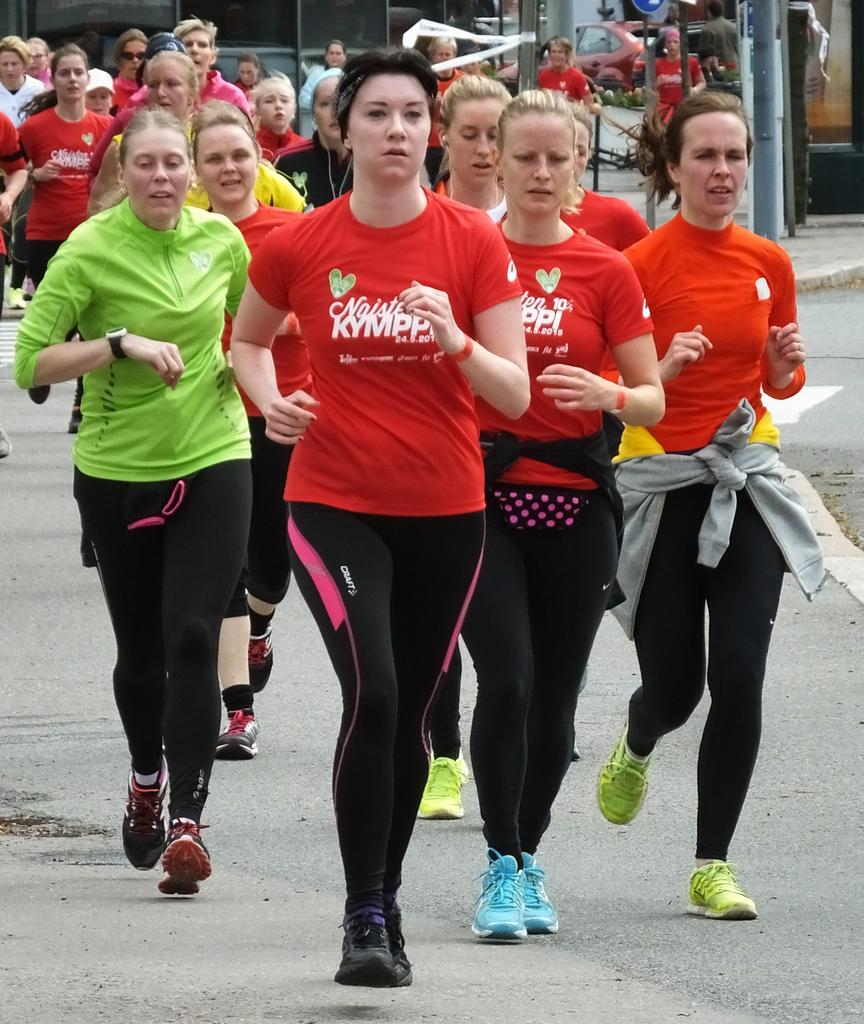What are the women in the image doing? The women in the image are running on the road. What can be seen on the sidewalk? There are sign boards on the sidewalk. What is the status of the car in the image? A car is parked in the image. What structures are visible in the background? There are buildings visible in the image. Who else is present in the image besides the women running? There is a man standing on the side in the image. What type of memory is the man holding in the image? There is no memory present in the image; it is a man standing on the side. 